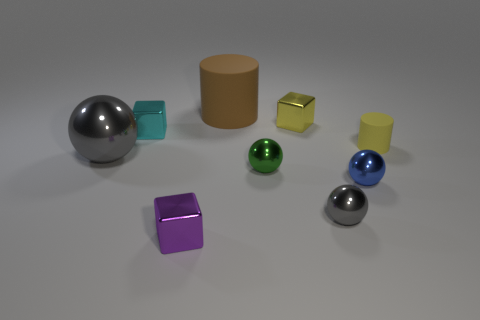Subtract all gray cubes. How many gray balls are left? 2 Subtract all big gray metal spheres. How many spheres are left? 3 Add 1 red metallic blocks. How many objects exist? 10 Subtract all brown balls. Subtract all yellow cylinders. How many balls are left? 4 Subtract all blocks. How many objects are left? 6 Add 4 cyan metal things. How many cyan metal things are left? 5 Add 5 green metallic balls. How many green metallic balls exist? 6 Subtract 0 gray cylinders. How many objects are left? 9 Subtract all yellow matte cylinders. Subtract all green balls. How many objects are left? 7 